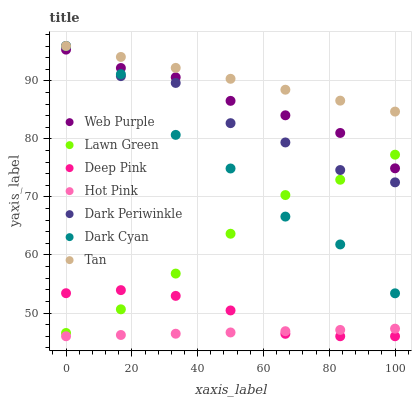Does Hot Pink have the minimum area under the curve?
Answer yes or no. Yes. Does Tan have the maximum area under the curve?
Answer yes or no. Yes. Does Deep Pink have the minimum area under the curve?
Answer yes or no. No. Does Deep Pink have the maximum area under the curve?
Answer yes or no. No. Is Hot Pink the smoothest?
Answer yes or no. Yes. Is Dark Cyan the roughest?
Answer yes or no. Yes. Is Deep Pink the smoothest?
Answer yes or no. No. Is Deep Pink the roughest?
Answer yes or no. No. Does Deep Pink have the lowest value?
Answer yes or no. Yes. Does Web Purple have the lowest value?
Answer yes or no. No. Does Dark Periwinkle have the highest value?
Answer yes or no. Yes. Does Deep Pink have the highest value?
Answer yes or no. No. Is Hot Pink less than Tan?
Answer yes or no. Yes. Is Tan greater than Deep Pink?
Answer yes or no. Yes. Does Dark Cyan intersect Lawn Green?
Answer yes or no. Yes. Is Dark Cyan less than Lawn Green?
Answer yes or no. No. Is Dark Cyan greater than Lawn Green?
Answer yes or no. No. Does Hot Pink intersect Tan?
Answer yes or no. No. 